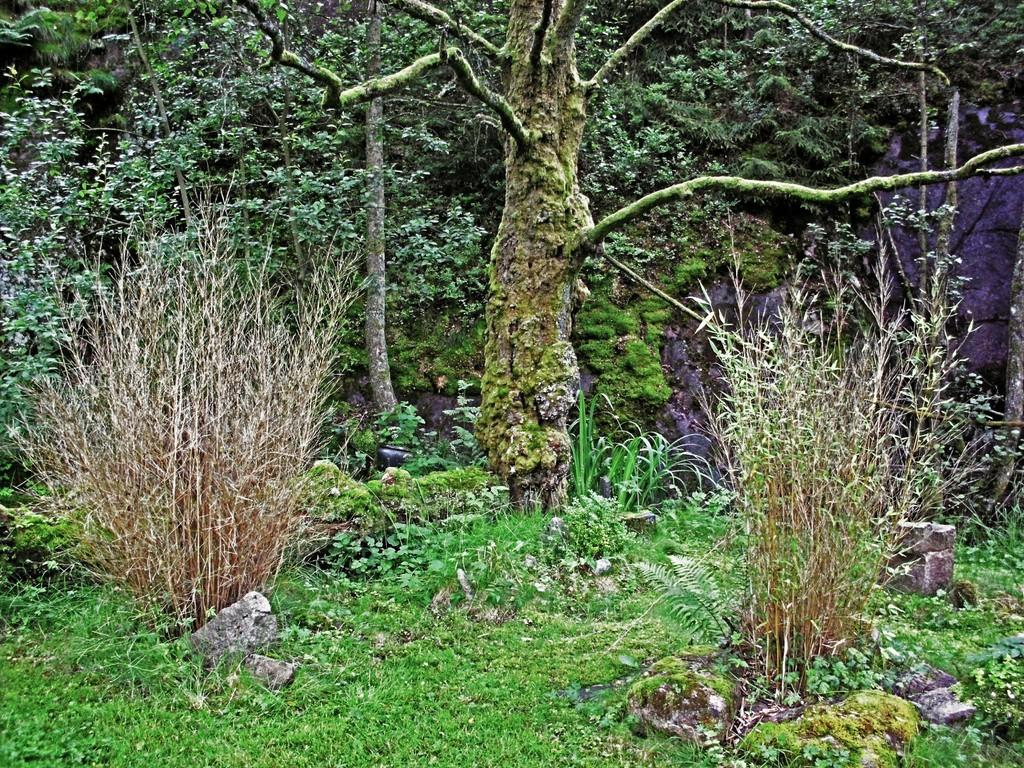What type of vegetation can be seen in the image? There is grass, brown plants, and green trees in the image. What other objects are present in the image besides vegetation? There are rocks in the image. Can you describe the color of the plants in the image? The plants are brown and green. What type of scent can be detected from the lawyer in the image? There is no lawyer present in the image, so it is not possible to detect any scent from one. 